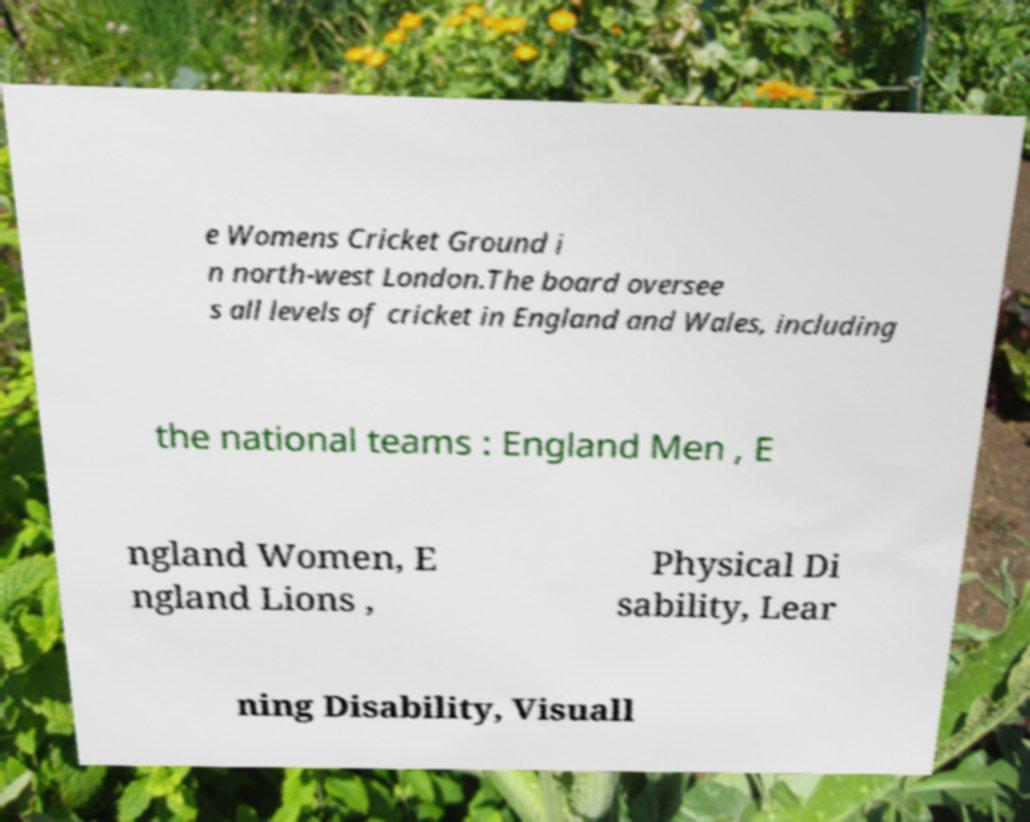Please identify and transcribe the text found in this image. e Womens Cricket Ground i n north-west London.The board oversee s all levels of cricket in England and Wales, including the national teams : England Men , E ngland Women, E ngland Lions , Physical Di sability, Lear ning Disability, Visuall 